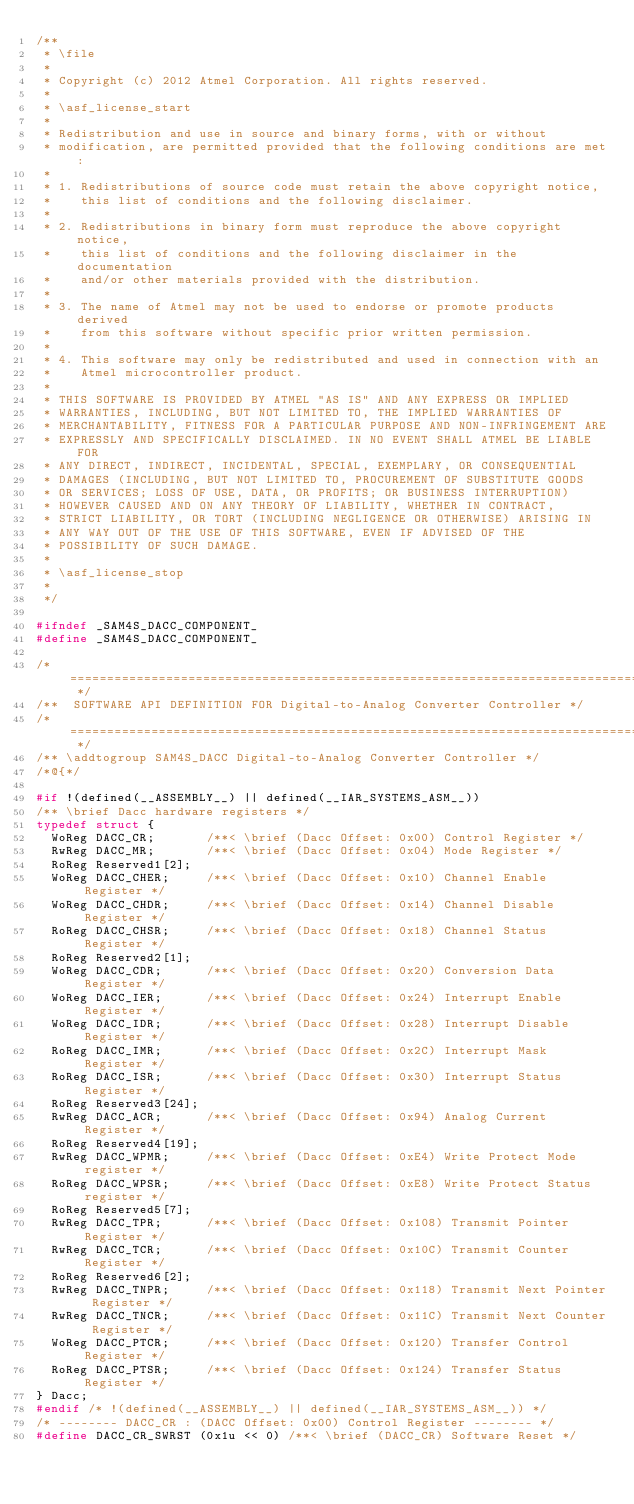<code> <loc_0><loc_0><loc_500><loc_500><_C_>/**
 * \file
 *
 * Copyright (c) 2012 Atmel Corporation. All rights reserved.
 *
 * \asf_license_start
 *
 * Redistribution and use in source and binary forms, with or without
 * modification, are permitted provided that the following conditions are met:
 *
 * 1. Redistributions of source code must retain the above copyright notice,
 *    this list of conditions and the following disclaimer.
 *
 * 2. Redistributions in binary form must reproduce the above copyright notice,
 *    this list of conditions and the following disclaimer in the documentation
 *    and/or other materials provided with the distribution.
 *
 * 3. The name of Atmel may not be used to endorse or promote products derived
 *    from this software without specific prior written permission.
 *
 * 4. This software may only be redistributed and used in connection with an
 *    Atmel microcontroller product.
 *
 * THIS SOFTWARE IS PROVIDED BY ATMEL "AS IS" AND ANY EXPRESS OR IMPLIED
 * WARRANTIES, INCLUDING, BUT NOT LIMITED TO, THE IMPLIED WARRANTIES OF
 * MERCHANTABILITY, FITNESS FOR A PARTICULAR PURPOSE AND NON-INFRINGEMENT ARE
 * EXPRESSLY AND SPECIFICALLY DISCLAIMED. IN NO EVENT SHALL ATMEL BE LIABLE FOR
 * ANY DIRECT, INDIRECT, INCIDENTAL, SPECIAL, EXEMPLARY, OR CONSEQUENTIAL
 * DAMAGES (INCLUDING, BUT NOT LIMITED TO, PROCUREMENT OF SUBSTITUTE GOODS
 * OR SERVICES; LOSS OF USE, DATA, OR PROFITS; OR BUSINESS INTERRUPTION)
 * HOWEVER CAUSED AND ON ANY THEORY OF LIABILITY, WHETHER IN CONTRACT,
 * STRICT LIABILITY, OR TORT (INCLUDING NEGLIGENCE OR OTHERWISE) ARISING IN
 * ANY WAY OUT OF THE USE OF THIS SOFTWARE, EVEN IF ADVISED OF THE
 * POSSIBILITY OF SUCH DAMAGE.
 *
 * \asf_license_stop
 *
 */

#ifndef _SAM4S_DACC_COMPONENT_
#define _SAM4S_DACC_COMPONENT_

/* ============================================================================= */
/**  SOFTWARE API DEFINITION FOR Digital-to-Analog Converter Controller */
/* ============================================================================= */
/** \addtogroup SAM4S_DACC Digital-to-Analog Converter Controller */
/*@{*/

#if !(defined(__ASSEMBLY__) || defined(__IAR_SYSTEMS_ASM__))
/** \brief Dacc hardware registers */
typedef struct {
  WoReg DACC_CR;       /**< \brief (Dacc Offset: 0x00) Control Register */
  RwReg DACC_MR;       /**< \brief (Dacc Offset: 0x04) Mode Register */
  RoReg Reserved1[2];
  WoReg DACC_CHER;     /**< \brief (Dacc Offset: 0x10) Channel Enable Register */
  WoReg DACC_CHDR;     /**< \brief (Dacc Offset: 0x14) Channel Disable Register */
  RoReg DACC_CHSR;     /**< \brief (Dacc Offset: 0x18) Channel Status Register */
  RoReg Reserved2[1];
  WoReg DACC_CDR;      /**< \brief (Dacc Offset: 0x20) Conversion Data Register */
  WoReg DACC_IER;      /**< \brief (Dacc Offset: 0x24) Interrupt Enable Register */
  WoReg DACC_IDR;      /**< \brief (Dacc Offset: 0x28) Interrupt Disable Register */
  RoReg DACC_IMR;      /**< \brief (Dacc Offset: 0x2C) Interrupt Mask Register */
  RoReg DACC_ISR;      /**< \brief (Dacc Offset: 0x30) Interrupt Status Register */
  RoReg Reserved3[24];
  RwReg DACC_ACR;      /**< \brief (Dacc Offset: 0x94) Analog Current Register */
  RoReg Reserved4[19];
  RwReg DACC_WPMR;     /**< \brief (Dacc Offset: 0xE4) Write Protect Mode register */
  RoReg DACC_WPSR;     /**< \brief (Dacc Offset: 0xE8) Write Protect Status register */
  RoReg Reserved5[7];
  RwReg DACC_TPR;      /**< \brief (Dacc Offset: 0x108) Transmit Pointer Register */
  RwReg DACC_TCR;      /**< \brief (Dacc Offset: 0x10C) Transmit Counter Register */
  RoReg Reserved6[2];
  RwReg DACC_TNPR;     /**< \brief (Dacc Offset: 0x118) Transmit Next Pointer Register */
  RwReg DACC_TNCR;     /**< \brief (Dacc Offset: 0x11C) Transmit Next Counter Register */
  WoReg DACC_PTCR;     /**< \brief (Dacc Offset: 0x120) Transfer Control Register */
  RoReg DACC_PTSR;     /**< \brief (Dacc Offset: 0x124) Transfer Status Register */
} Dacc;
#endif /* !(defined(__ASSEMBLY__) || defined(__IAR_SYSTEMS_ASM__)) */
/* -------- DACC_CR : (DACC Offset: 0x00) Control Register -------- */
#define DACC_CR_SWRST (0x1u << 0) /**< \brief (DACC_CR) Software Reset */</code> 